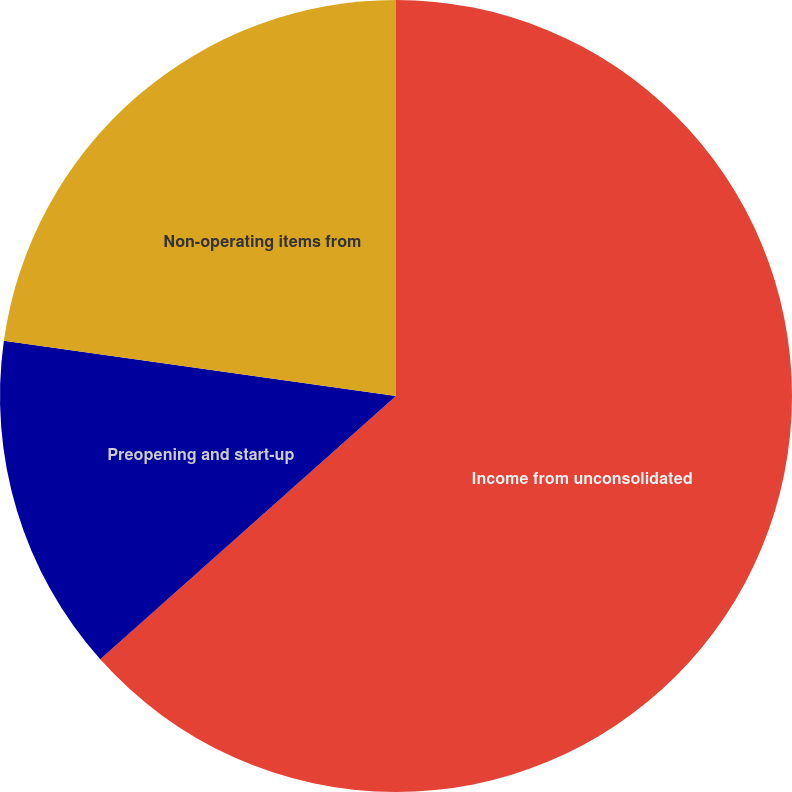<chart> <loc_0><loc_0><loc_500><loc_500><pie_chart><fcel>Income from unconsolidated<fcel>Preopening and start-up<fcel>Non-operating items from<nl><fcel>63.42%<fcel>13.81%<fcel>22.77%<nl></chart> 